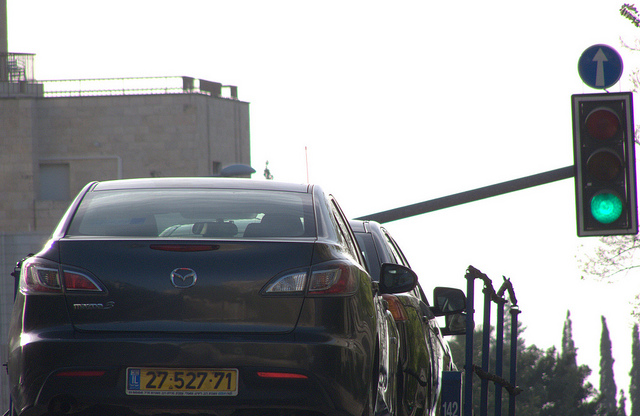Please transcribe the text information in this image. 27.527.71 